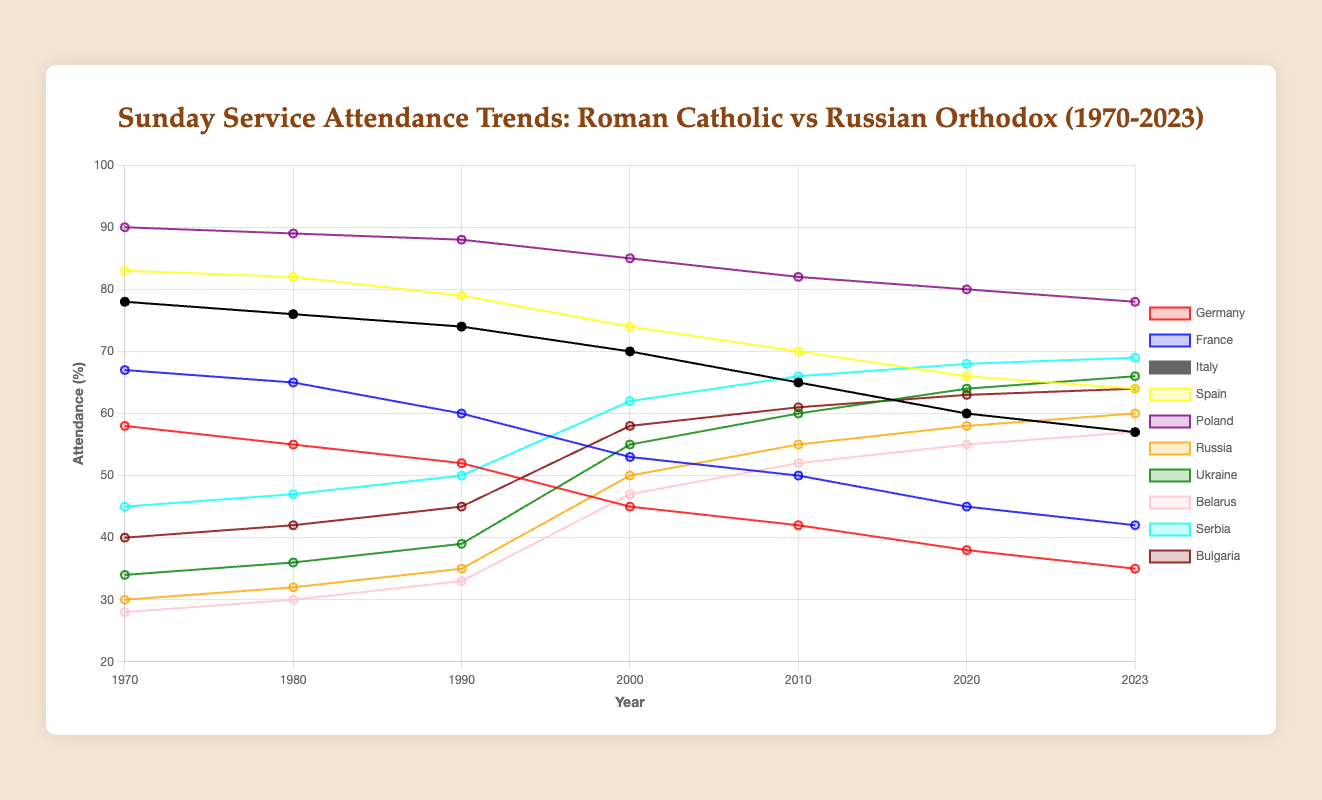What's the attendance trend for Roman Catholic parishes in Germany from 1970 to 2023? The figure shows the attendance of Roman Catholic parishes in Germany declining from 58% in 1970 to 35% in 2023. This is a straightforward downward trend.
Answer: Declining from 58% to 35% Which country had the highest Sunday service attendance among Roman Catholic parishes in 1970? By examining the figure, it's clear that Poland had the highest attendance among Roman Catholic parishes in 1970 with 90%.
Answer: Poland (90%) Between 2000 and 2023, which Russian Orthodox country saw the largest increase in Sunday service attendance? Compare the attendance values of Russian Orthodox countries between 2000 and 2023. Russia increased from 50% to 60%, Ukraine from 55% to 66%, Belarus from 47% to 57%, Serbia from 62% to 69%, and Bulgaria from 58% to 64%. Ukraine has the highest increase (11%).
Answer: Ukraine (11%) What is the average Sunday service attendance for Roman Catholic parishes in Spain across all recorded years? Calculate the average by summing up the values from each recorded year and dividing by the number of years. The total attendance from 1970 to 2023 are (83 + 82 + 79 + 74 + 70 + 66 + 64) = 518. There are 7 years of data, so 518 / 7 = ~74%
Answer: ~74% Comparing France and Italy, which country had a steeper decline in Roman Catholic Sunday service attendance from 1970 to 2023? For France: 67% to 42% (a 25-point decline). For Italy: 78% to 57% (a 21-point decline). Thus, France had a steeper decline.
Answer: France (25%) How does the Sunday service attendance in Russia in 2023 compare to that in Germany? Visual comparison of the attendance in 2023 shows that Russia (60%) has a higher attendance than Germany (35%).
Answer: Russia has higher attendance (60% vs 35%) Which country among the Russian Orthodox had the lowest attendance in 1970? By checking the values for Russian Orthodox countries in 1970, Belarus had the lowest attendance with 28%.
Answer: Belarus (28%) What was the combined Roman Catholic attendance in Poland and Spain in 2023? Add the attendance values for Poland (78%) and Spain (64%) in 2023: 78 + 64 = 142%.
Answer: 142% Has any country (Roman Catholic or Russian Orthodox) shown an increase in Sunday service attendance from 1970 to 2023? If yes, name them. By looking at the span from 1970 to 2023, only the Russian Orthodox countries show an overall increase. Specifically, Russia, Ukraine, Belarus, Serbia, and Bulgaria all increased in attendance.
Answer: Russia, Ukraine, Belarus, Serbia, Bulgaria 